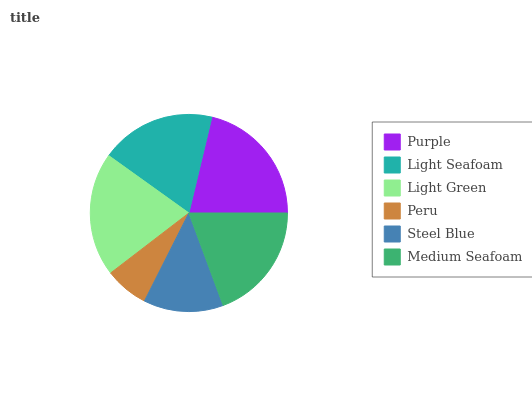Is Peru the minimum?
Answer yes or no. Yes. Is Purple the maximum?
Answer yes or no. Yes. Is Light Seafoam the minimum?
Answer yes or no. No. Is Light Seafoam the maximum?
Answer yes or no. No. Is Purple greater than Light Seafoam?
Answer yes or no. Yes. Is Light Seafoam less than Purple?
Answer yes or no. Yes. Is Light Seafoam greater than Purple?
Answer yes or no. No. Is Purple less than Light Seafoam?
Answer yes or no. No. Is Medium Seafoam the high median?
Answer yes or no. Yes. Is Light Seafoam the low median?
Answer yes or no. Yes. Is Purple the high median?
Answer yes or no. No. Is Light Green the low median?
Answer yes or no. No. 